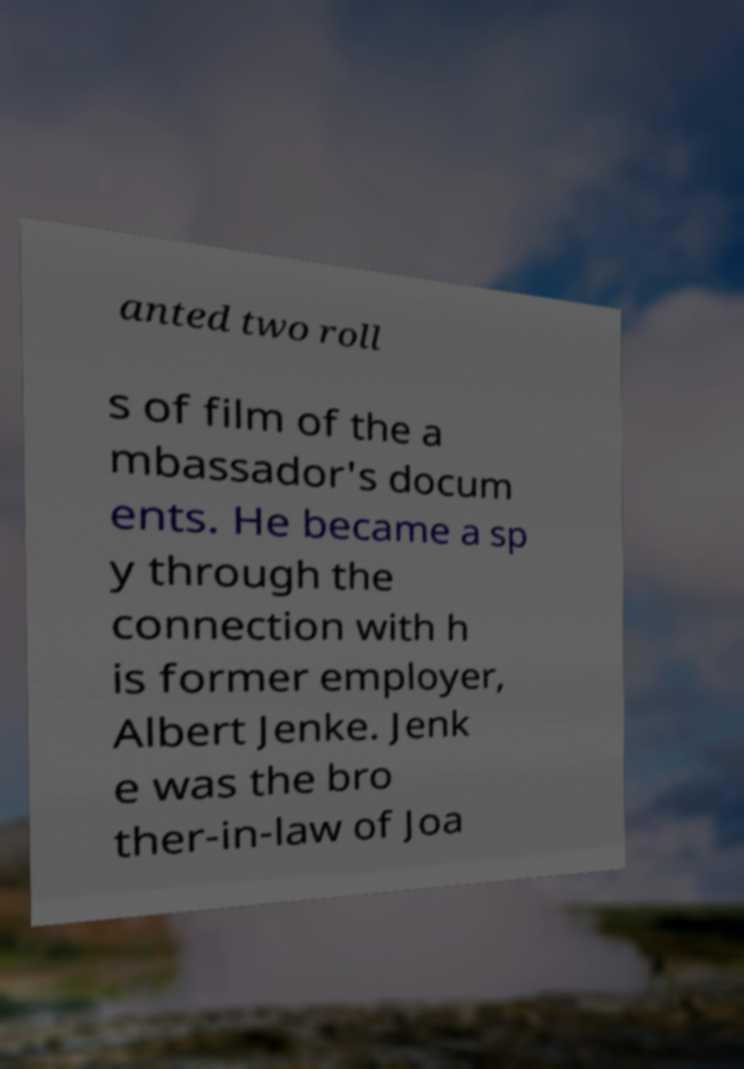Can you accurately transcribe the text from the provided image for me? anted two roll s of film of the a mbassador's docum ents. He became a sp y through the connection with h is former employer, Albert Jenke. Jenk e was the bro ther-in-law of Joa 